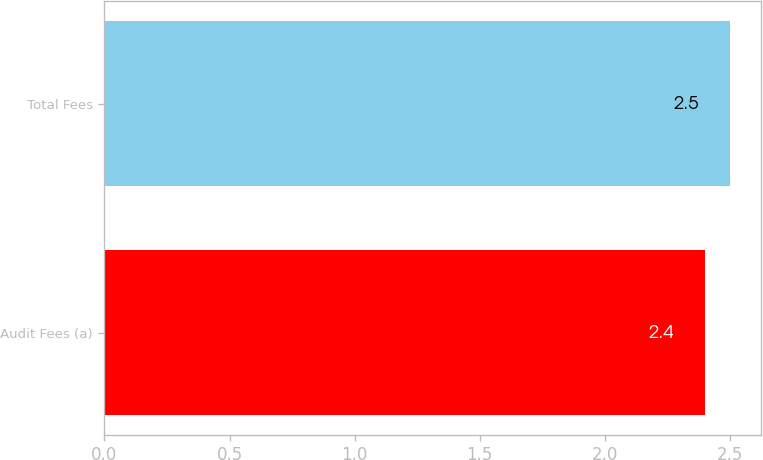<chart> <loc_0><loc_0><loc_500><loc_500><bar_chart><fcel>Audit Fees (a)<fcel>Total Fees<nl><fcel>2.4<fcel>2.5<nl></chart> 